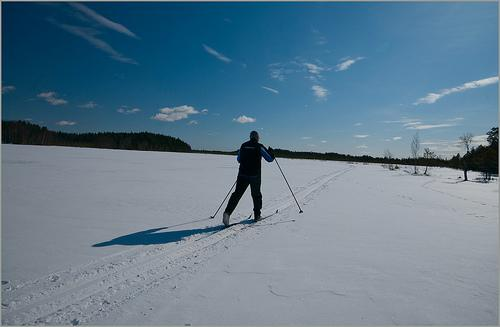Question: what is on the ground?
Choices:
A. Leaves.
B. Snow.
C. Trash.
D. Stones.
Answer with the letter. Answer: B Question: who is using skis?
Choices:
A. Woman.
B. Kids.
C. Teachers.
D. Man.
Answer with the letter. Answer: D Question: when was this taken?
Choices:
A. Summer.
B. Yesterday.
C. Wednesday.
D. Winter.
Answer with the letter. Answer: D Question: where is the snow?
Choices:
A. Falling.
B. On the mountain.
C. On the car.
D. On the ground.
Answer with the letter. Answer: D Question: what sport is this?
Choices:
A. Football.
B. Cross country skiing.
C. Soccer.
D. Baseball.
Answer with the letter. Answer: B Question: what is in the man's hands?
Choices:
A. HIs hat.
B. His goggles.
C. Ski poles.
D. His lift ticket.
Answer with the letter. Answer: C 